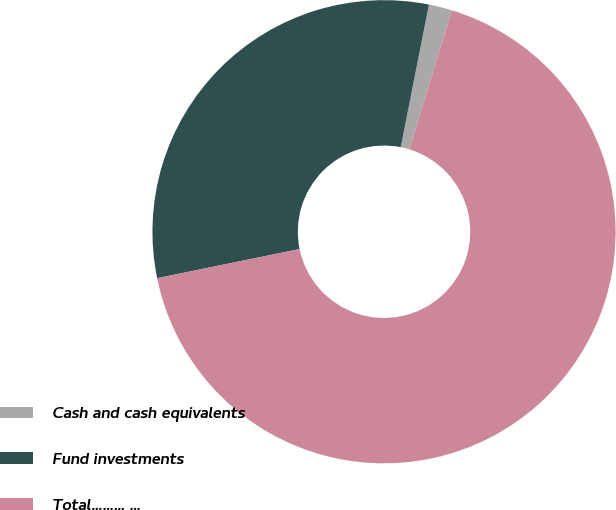Convert chart. <chart><loc_0><loc_0><loc_500><loc_500><pie_chart><fcel>Cash and cash equivalents<fcel>Fund investments<fcel>Total……… …<nl><fcel>1.63%<fcel>31.32%<fcel>67.05%<nl></chart> 